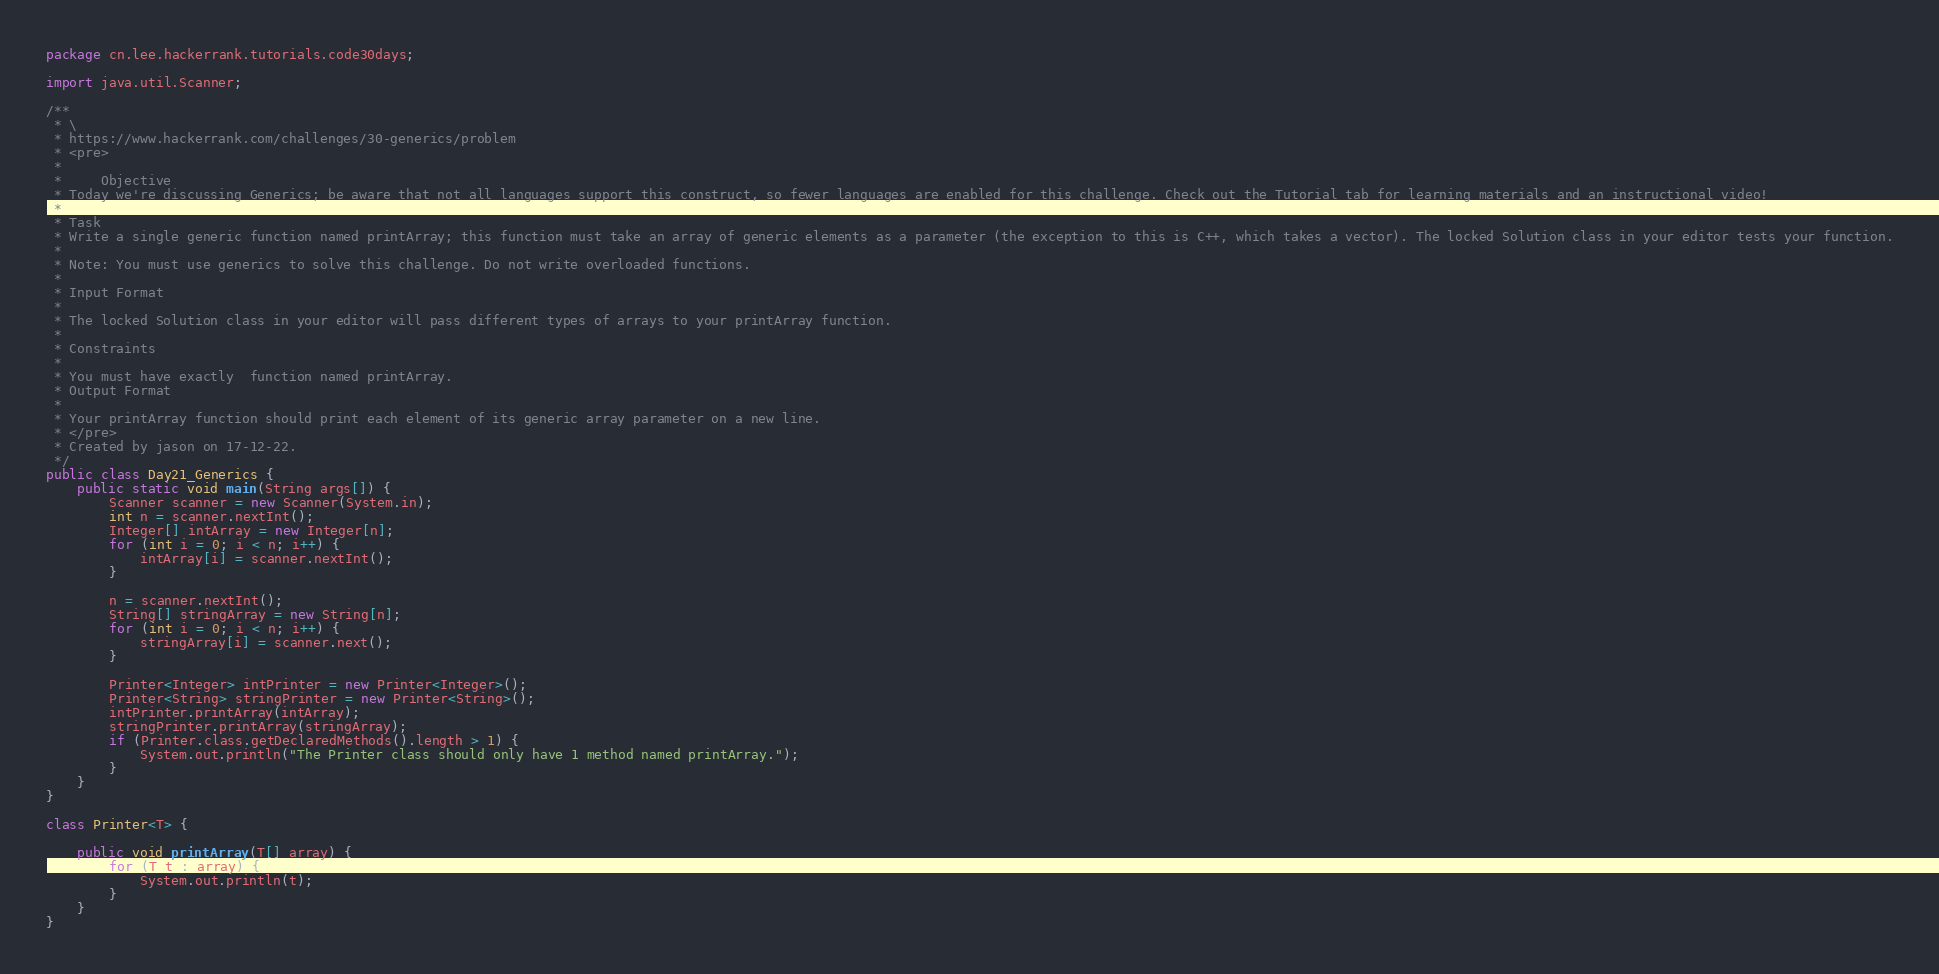<code> <loc_0><loc_0><loc_500><loc_500><_Java_>package cn.lee.hackerrank.tutorials.code30days;

import java.util.Scanner;

/**
 * \
 * https://www.hackerrank.com/challenges/30-generics/problem
 * <pre>
 *
 *     Objective
 * Today we're discussing Generics; be aware that not all languages support this construct, so fewer languages are enabled for this challenge. Check out the Tutorial tab for learning materials and an instructional video!
 *
 * Task
 * Write a single generic function named printArray; this function must take an array of generic elements as a parameter (the exception to this is C++, which takes a vector). The locked Solution class in your editor tests your function.
 *
 * Note: You must use generics to solve this challenge. Do not write overloaded functions.
 *
 * Input Format
 *
 * The locked Solution class in your editor will pass different types of arrays to your printArray function.
 *
 * Constraints
 *
 * You must have exactly  function named printArray.
 * Output Format
 *
 * Your printArray function should print each element of its generic array parameter on a new line.
 * </pre>
 * Created by jason on 17-12-22.
 */
public class Day21_Generics {
    public static void main(String args[]) {
        Scanner scanner = new Scanner(System.in);
        int n = scanner.nextInt();
        Integer[] intArray = new Integer[n];
        for (int i = 0; i < n; i++) {
            intArray[i] = scanner.nextInt();
        }

        n = scanner.nextInt();
        String[] stringArray = new String[n];
        for (int i = 0; i < n; i++) {
            stringArray[i] = scanner.next();
        }

        Printer<Integer> intPrinter = new Printer<Integer>();
        Printer<String> stringPrinter = new Printer<String>();
        intPrinter.printArray(intArray);
        stringPrinter.printArray(stringArray);
        if (Printer.class.getDeclaredMethods().length > 1) {
            System.out.println("The Printer class should only have 1 method named printArray.");
        }
    }
}

class Printer<T> {

    public void printArray(T[] array) {
        for (T t : array) {
            System.out.println(t);
        }
    }
}</code> 